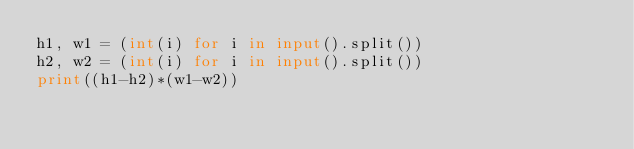Convert code to text. <code><loc_0><loc_0><loc_500><loc_500><_Python_>h1, w1 = (int(i) for i in input().split())
h2, w2 = (int(i) for i in input().split())
print((h1-h2)*(w1-w2))</code> 